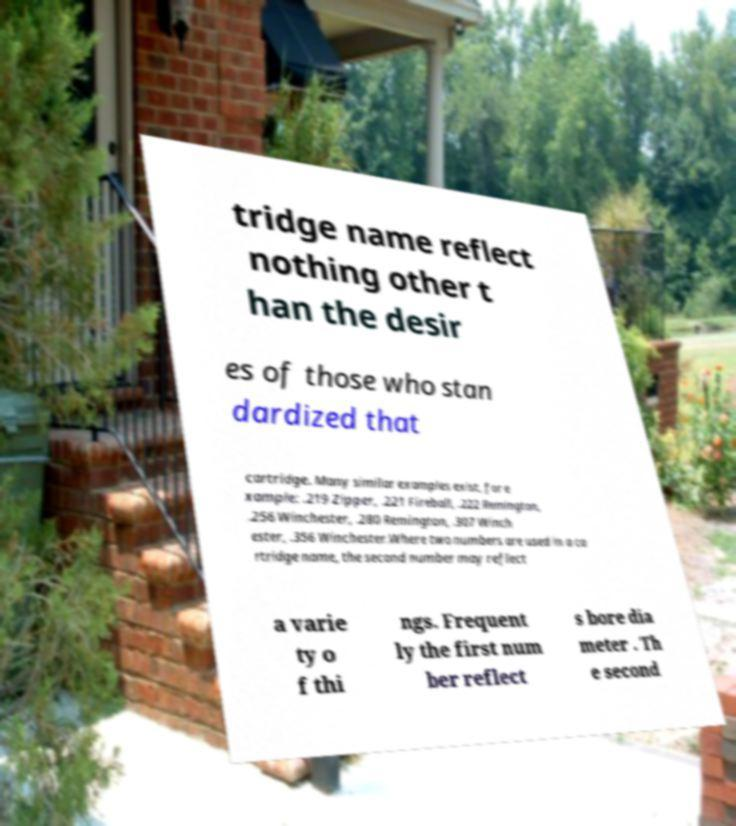What messages or text are displayed in this image? I need them in a readable, typed format. tridge name reflect nothing other t han the desir es of those who stan dardized that cartridge. Many similar examples exist, for e xample: .219 Zipper, .221 Fireball, .222 Remington, .256 Winchester, .280 Remington, .307 Winch ester, .356 Winchester.Where two numbers are used in a ca rtridge name, the second number may reflect a varie ty o f thi ngs. Frequent ly the first num ber reflect s bore dia meter . Th e second 